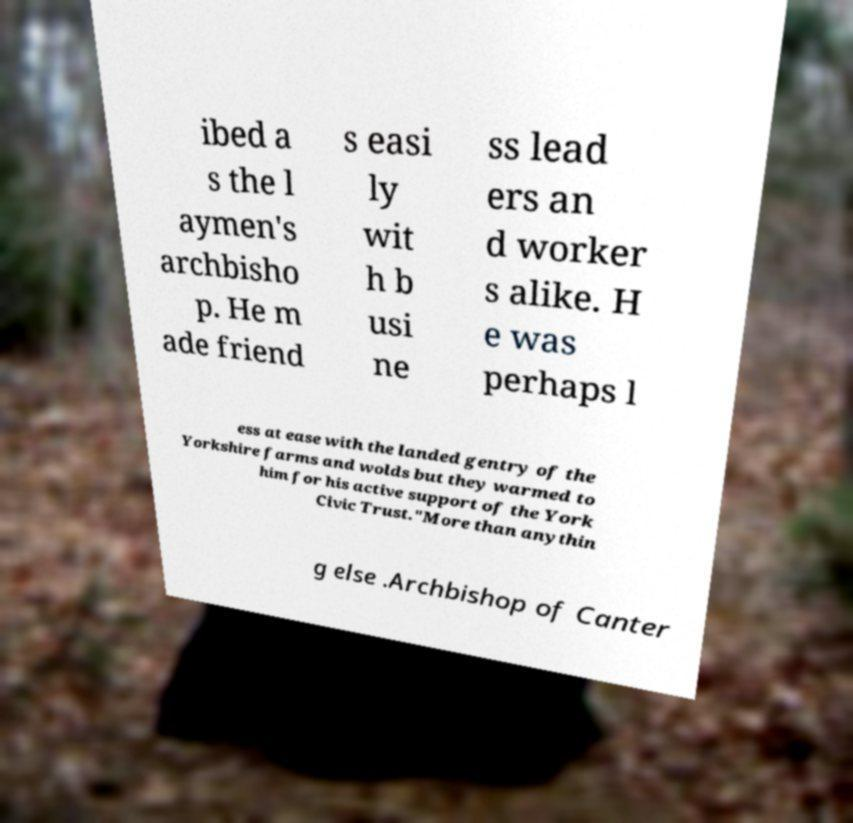Could you extract and type out the text from this image? ibed a s the l aymen's archbisho p. He m ade friend s easi ly wit h b usi ne ss lead ers an d worker s alike. H e was perhaps l ess at ease with the landed gentry of the Yorkshire farms and wolds but they warmed to him for his active support of the York Civic Trust."More than anythin g else .Archbishop of Canter 